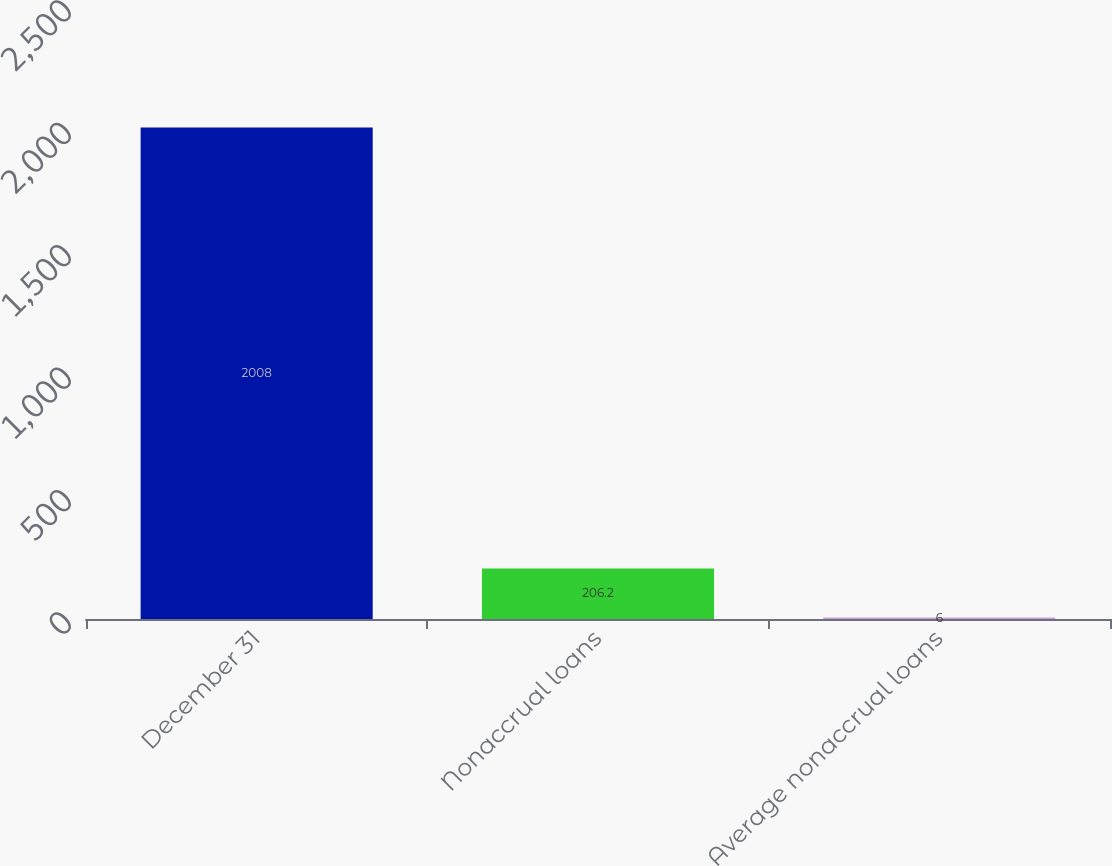Convert chart to OTSL. <chart><loc_0><loc_0><loc_500><loc_500><bar_chart><fcel>December 31<fcel>Nonaccrual loans<fcel>Average nonaccrual loans<nl><fcel>2008<fcel>206.2<fcel>6<nl></chart> 